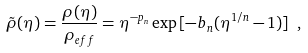Convert formula to latex. <formula><loc_0><loc_0><loc_500><loc_500>\tilde { \rho } ( \eta ) = \frac { \rho ( \eta ) } { \rho _ { e f f } } = \eta ^ { - p _ { n } } \exp { [ - b _ { n } ( \eta ^ { 1 / n } - 1 ) ] } \ ,</formula> 